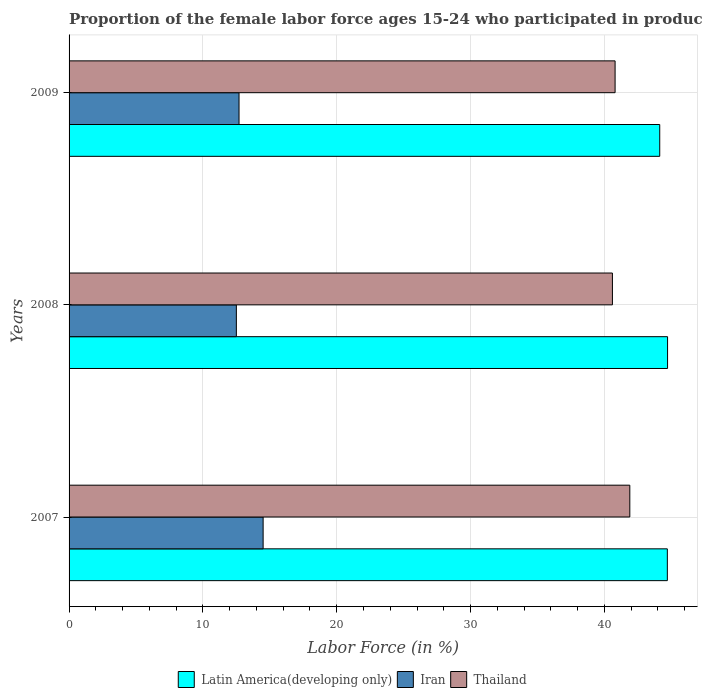How many different coloured bars are there?
Your answer should be compact. 3. How many groups of bars are there?
Your answer should be compact. 3. Are the number of bars per tick equal to the number of legend labels?
Give a very brief answer. Yes. How many bars are there on the 2nd tick from the top?
Keep it short and to the point. 3. In how many cases, is the number of bars for a given year not equal to the number of legend labels?
Make the answer very short. 0. What is the proportion of the female labor force who participated in production in Thailand in 2008?
Provide a succinct answer. 40.6. Across all years, what is the maximum proportion of the female labor force who participated in production in Thailand?
Ensure brevity in your answer.  41.9. What is the total proportion of the female labor force who participated in production in Latin America(developing only) in the graph?
Ensure brevity in your answer.  133.56. What is the difference between the proportion of the female labor force who participated in production in Thailand in 2007 and that in 2008?
Your response must be concise. 1.3. What is the difference between the proportion of the female labor force who participated in production in Thailand in 2009 and the proportion of the female labor force who participated in production in Latin America(developing only) in 2007?
Your answer should be compact. -3.9. What is the average proportion of the female labor force who participated in production in Latin America(developing only) per year?
Give a very brief answer. 44.52. In the year 2009, what is the difference between the proportion of the female labor force who participated in production in Iran and proportion of the female labor force who participated in production in Latin America(developing only)?
Keep it short and to the point. -31.44. What is the ratio of the proportion of the female labor force who participated in production in Latin America(developing only) in 2007 to that in 2008?
Your response must be concise. 1. Is the difference between the proportion of the female labor force who participated in production in Iran in 2007 and 2008 greater than the difference between the proportion of the female labor force who participated in production in Latin America(developing only) in 2007 and 2008?
Your answer should be very brief. Yes. What is the difference between the highest and the second highest proportion of the female labor force who participated in production in Thailand?
Ensure brevity in your answer.  1.1. What is the difference between the highest and the lowest proportion of the female labor force who participated in production in Iran?
Your response must be concise. 2. What does the 3rd bar from the top in 2007 represents?
Give a very brief answer. Latin America(developing only). What does the 3rd bar from the bottom in 2007 represents?
Your answer should be compact. Thailand. Is it the case that in every year, the sum of the proportion of the female labor force who participated in production in Iran and proportion of the female labor force who participated in production in Thailand is greater than the proportion of the female labor force who participated in production in Latin America(developing only)?
Your answer should be compact. Yes. What is the difference between two consecutive major ticks on the X-axis?
Ensure brevity in your answer.  10. Are the values on the major ticks of X-axis written in scientific E-notation?
Provide a short and direct response. No. Does the graph contain any zero values?
Offer a terse response. No. How many legend labels are there?
Provide a succinct answer. 3. What is the title of the graph?
Offer a very short reply. Proportion of the female labor force ages 15-24 who participated in production. What is the label or title of the X-axis?
Keep it short and to the point. Labor Force (in %). What is the label or title of the Y-axis?
Offer a terse response. Years. What is the Labor Force (in %) of Latin America(developing only) in 2007?
Your answer should be very brief. 44.7. What is the Labor Force (in %) of Thailand in 2007?
Give a very brief answer. 41.9. What is the Labor Force (in %) of Latin America(developing only) in 2008?
Offer a terse response. 44.72. What is the Labor Force (in %) in Thailand in 2008?
Ensure brevity in your answer.  40.6. What is the Labor Force (in %) in Latin America(developing only) in 2009?
Offer a terse response. 44.14. What is the Labor Force (in %) in Iran in 2009?
Your response must be concise. 12.7. What is the Labor Force (in %) in Thailand in 2009?
Your answer should be very brief. 40.8. Across all years, what is the maximum Labor Force (in %) of Latin America(developing only)?
Your answer should be compact. 44.72. Across all years, what is the maximum Labor Force (in %) in Iran?
Ensure brevity in your answer.  14.5. Across all years, what is the maximum Labor Force (in %) in Thailand?
Keep it short and to the point. 41.9. Across all years, what is the minimum Labor Force (in %) in Latin America(developing only)?
Offer a very short reply. 44.14. Across all years, what is the minimum Labor Force (in %) in Iran?
Your answer should be very brief. 12.5. Across all years, what is the minimum Labor Force (in %) in Thailand?
Keep it short and to the point. 40.6. What is the total Labor Force (in %) in Latin America(developing only) in the graph?
Offer a very short reply. 133.56. What is the total Labor Force (in %) in Iran in the graph?
Your answer should be compact. 39.7. What is the total Labor Force (in %) in Thailand in the graph?
Make the answer very short. 123.3. What is the difference between the Labor Force (in %) in Latin America(developing only) in 2007 and that in 2008?
Provide a short and direct response. -0.02. What is the difference between the Labor Force (in %) of Latin America(developing only) in 2007 and that in 2009?
Keep it short and to the point. 0.57. What is the difference between the Labor Force (in %) in Latin America(developing only) in 2008 and that in 2009?
Your answer should be very brief. 0.59. What is the difference between the Labor Force (in %) in Thailand in 2008 and that in 2009?
Your response must be concise. -0.2. What is the difference between the Labor Force (in %) of Latin America(developing only) in 2007 and the Labor Force (in %) of Iran in 2008?
Offer a very short reply. 32.2. What is the difference between the Labor Force (in %) in Latin America(developing only) in 2007 and the Labor Force (in %) in Thailand in 2008?
Your response must be concise. 4.1. What is the difference between the Labor Force (in %) in Iran in 2007 and the Labor Force (in %) in Thailand in 2008?
Your answer should be very brief. -26.1. What is the difference between the Labor Force (in %) of Latin America(developing only) in 2007 and the Labor Force (in %) of Iran in 2009?
Give a very brief answer. 32. What is the difference between the Labor Force (in %) of Latin America(developing only) in 2007 and the Labor Force (in %) of Thailand in 2009?
Offer a very short reply. 3.9. What is the difference between the Labor Force (in %) in Iran in 2007 and the Labor Force (in %) in Thailand in 2009?
Offer a terse response. -26.3. What is the difference between the Labor Force (in %) of Latin America(developing only) in 2008 and the Labor Force (in %) of Iran in 2009?
Your answer should be very brief. 32.02. What is the difference between the Labor Force (in %) in Latin America(developing only) in 2008 and the Labor Force (in %) in Thailand in 2009?
Your answer should be very brief. 3.92. What is the difference between the Labor Force (in %) of Iran in 2008 and the Labor Force (in %) of Thailand in 2009?
Offer a terse response. -28.3. What is the average Labor Force (in %) in Latin America(developing only) per year?
Offer a very short reply. 44.52. What is the average Labor Force (in %) of Iran per year?
Ensure brevity in your answer.  13.23. What is the average Labor Force (in %) in Thailand per year?
Keep it short and to the point. 41.1. In the year 2007, what is the difference between the Labor Force (in %) of Latin America(developing only) and Labor Force (in %) of Iran?
Your response must be concise. 30.2. In the year 2007, what is the difference between the Labor Force (in %) in Latin America(developing only) and Labor Force (in %) in Thailand?
Your answer should be compact. 2.8. In the year 2007, what is the difference between the Labor Force (in %) in Iran and Labor Force (in %) in Thailand?
Provide a short and direct response. -27.4. In the year 2008, what is the difference between the Labor Force (in %) of Latin America(developing only) and Labor Force (in %) of Iran?
Your answer should be very brief. 32.22. In the year 2008, what is the difference between the Labor Force (in %) of Latin America(developing only) and Labor Force (in %) of Thailand?
Offer a terse response. 4.12. In the year 2008, what is the difference between the Labor Force (in %) in Iran and Labor Force (in %) in Thailand?
Provide a short and direct response. -28.1. In the year 2009, what is the difference between the Labor Force (in %) in Latin America(developing only) and Labor Force (in %) in Iran?
Your answer should be compact. 31.44. In the year 2009, what is the difference between the Labor Force (in %) in Latin America(developing only) and Labor Force (in %) in Thailand?
Offer a very short reply. 3.34. In the year 2009, what is the difference between the Labor Force (in %) of Iran and Labor Force (in %) of Thailand?
Your response must be concise. -28.1. What is the ratio of the Labor Force (in %) of Iran in 2007 to that in 2008?
Offer a terse response. 1.16. What is the ratio of the Labor Force (in %) of Thailand in 2007 to that in 2008?
Provide a succinct answer. 1.03. What is the ratio of the Labor Force (in %) in Latin America(developing only) in 2007 to that in 2009?
Your answer should be very brief. 1.01. What is the ratio of the Labor Force (in %) of Iran in 2007 to that in 2009?
Offer a terse response. 1.14. What is the ratio of the Labor Force (in %) of Latin America(developing only) in 2008 to that in 2009?
Offer a terse response. 1.01. What is the ratio of the Labor Force (in %) of Iran in 2008 to that in 2009?
Provide a short and direct response. 0.98. What is the difference between the highest and the second highest Labor Force (in %) of Latin America(developing only)?
Make the answer very short. 0.02. What is the difference between the highest and the second highest Labor Force (in %) of Thailand?
Your answer should be very brief. 1.1. What is the difference between the highest and the lowest Labor Force (in %) of Latin America(developing only)?
Make the answer very short. 0.59. What is the difference between the highest and the lowest Labor Force (in %) in Iran?
Give a very brief answer. 2. What is the difference between the highest and the lowest Labor Force (in %) of Thailand?
Your response must be concise. 1.3. 